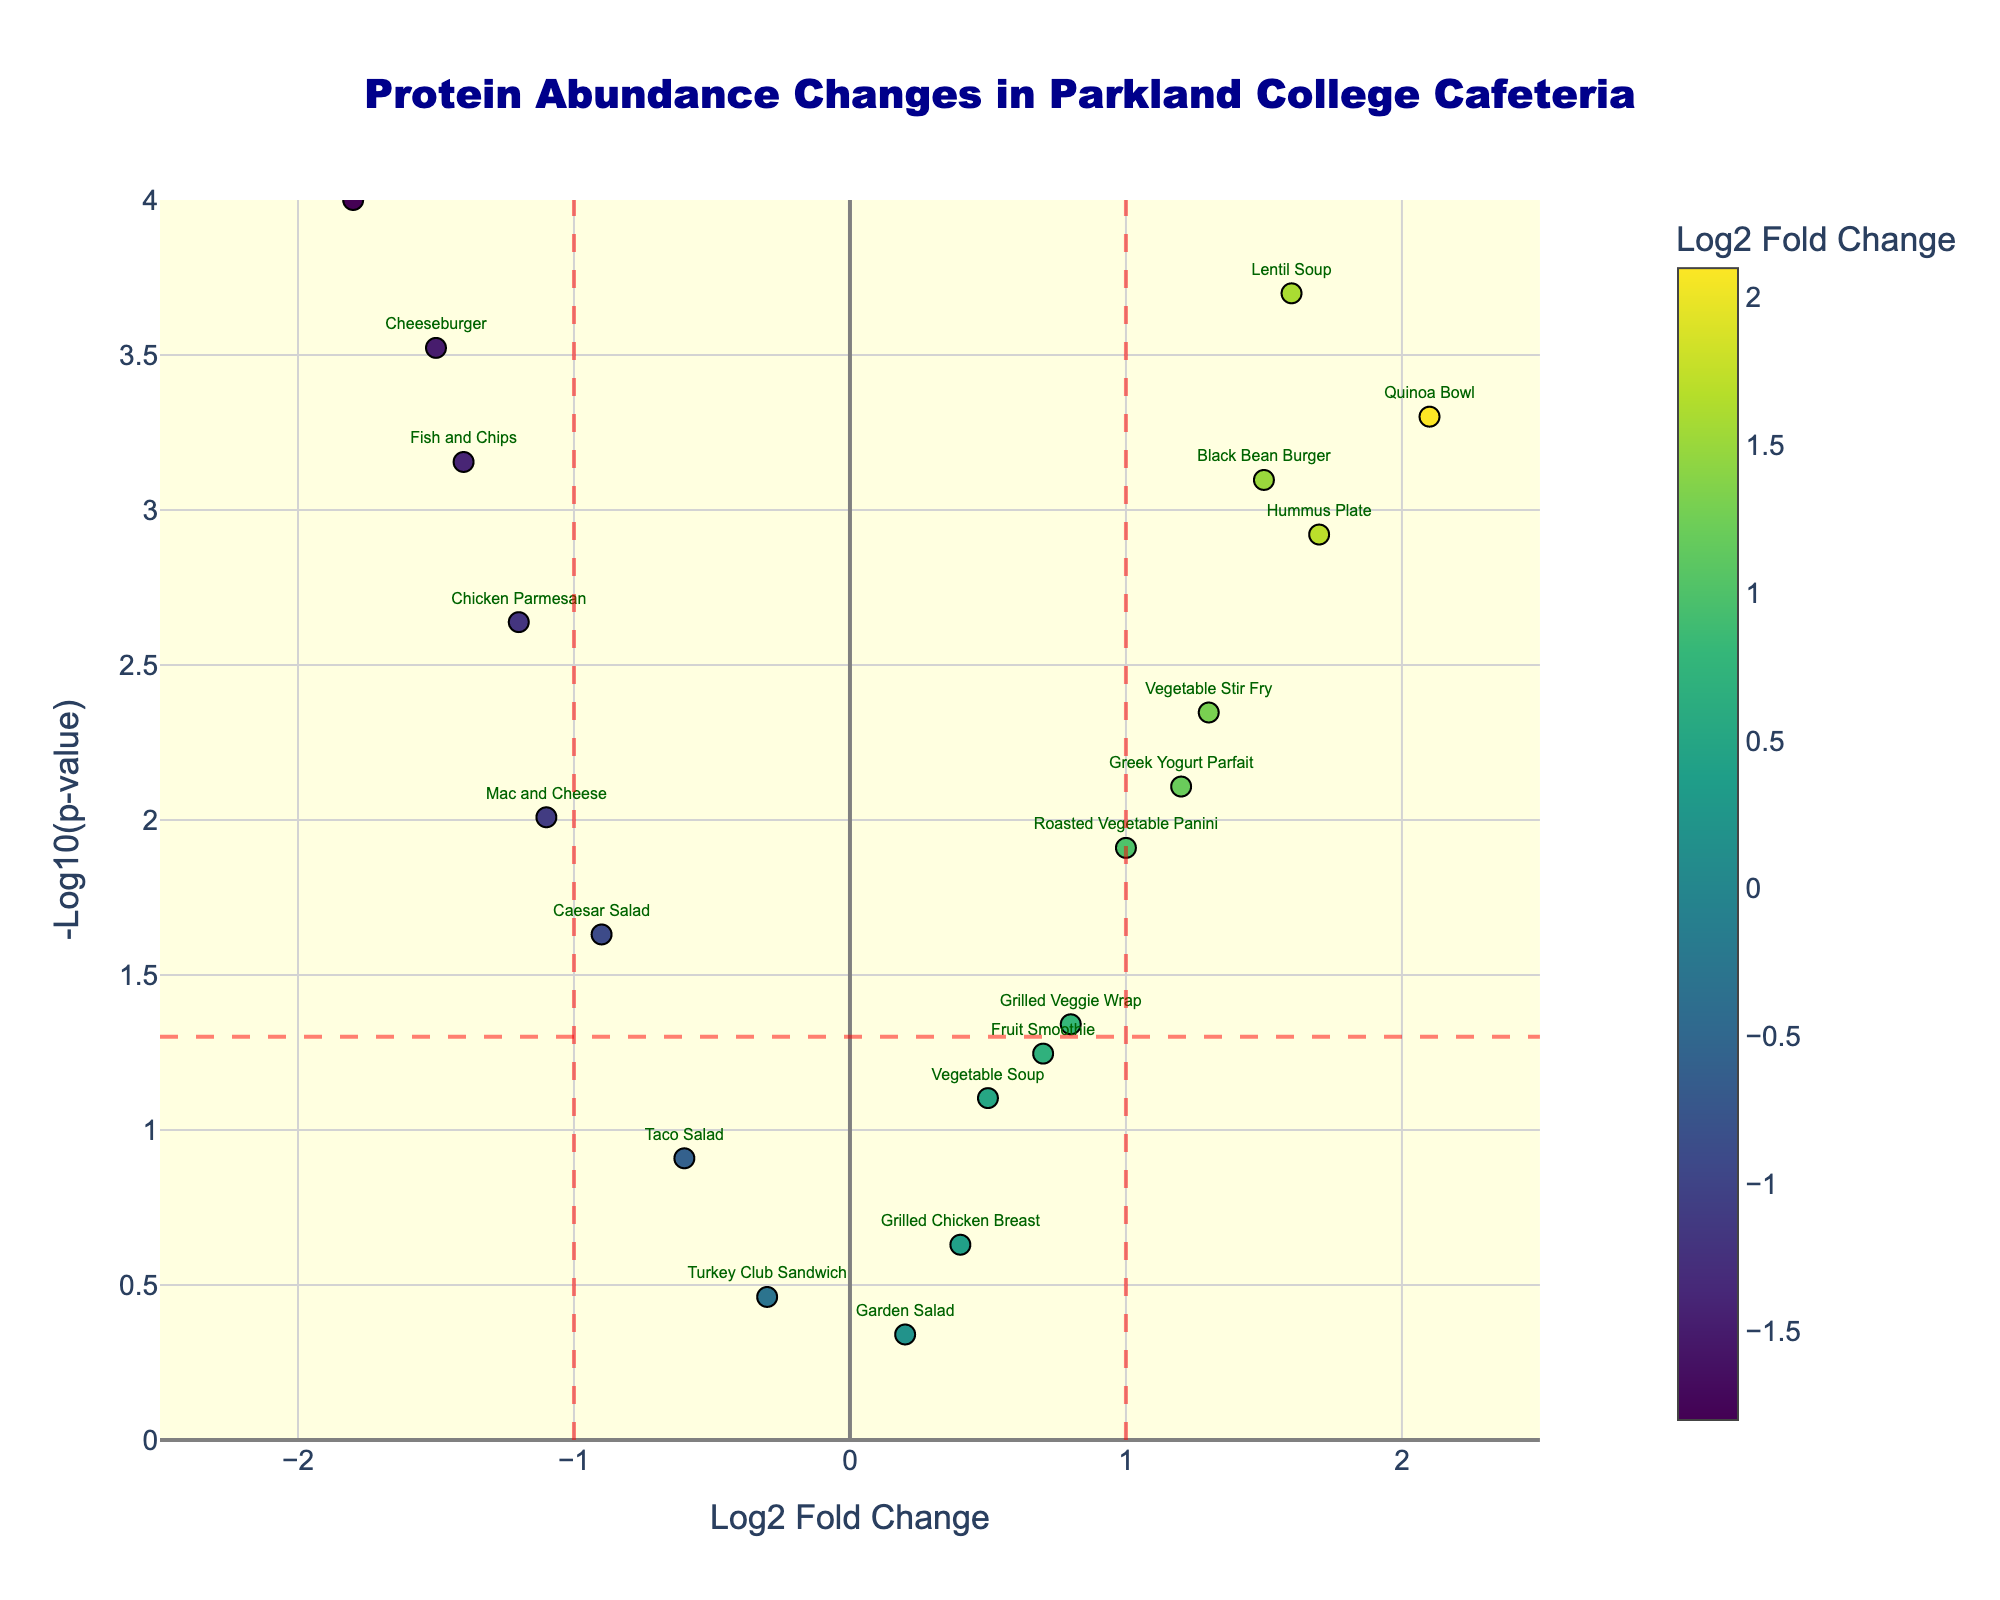What's the title of the plot? The title is usually displayed at the top of the plot and provides an overview of the figure. Here, it reads "Protein Abundance Changes in Parkland College Cafeteria."
Answer: Protein Abundance Changes in Parkland College Cafeteria What are the x-axis and y-axis titles? The x-axis and y-axis titles help understand what measurements are used. In this plot, the x-axis title is "Log2 Fold Change," and the y-axis title is "-Log10(p-value)."
Answer: Log2 Fold Change, -Log10(p-value) Which protein has the highest -log10(p-value)? By observing the y-axis values, the highest -log10(p-value) is 4 (indicating the smallest p-value), and the corresponding protein text label is "Spinach Artichoke Dip."
Answer: Spinach Artichoke Dip Which protein shows the most significant increase in abundance after the menu update? The most significant increase in abundance will have the highest positive log2FoldChange. "Quinoa Bowl" with a log2FoldChange of 2.1 has the highest positive value.
Answer: Quinoa Bowl How many proteins are significantly different before and after the menu update? Significant differences are marked by points outside the vertical lines at x = ±1 and above the horizontal significance threshold at -log10(p-value) of 1.3. By counting, there are 8 such significant points.
Answer: 8 Which protein has the most significant decrease in abundance after the menu update? A significant decrease is represented by a high negative log2FoldChange. "Spinach Artichoke Dip" with a log2FoldChange of -1.8 has the lowest value.
Answer: Spinach Artichoke Dip Is the Cheeseburger more or less abundant after the menu updates? The Cheeseburger's log2FoldChange is negative (-1.5), indicating it is less abundant.
Answer: Less abundant What is the significance threshold for the p-value? The threshold for significance is indicated by the horizontal red dashed line on the y-axis, which is set at -log10(p-value) = 1.3, corresponding to a p-value of 0.05.
Answer: 0.05 Are any proteins close to the significance threshold but not quite significant? If so, which ones? Proteins close to but below the significance threshold line (y = 1.3) include "Taco Salad" and "Vegetable Soup." Their -log10(p-value) values are slightly lower than the threshold.
Answer: Taco Salad, Vegetable Soup Which proteins show a fold change (either positive or negative) below 0.5 and above -0.5? Proteins within the range of -0.5 to +0.5 log2FoldChange include "Garden Salad" (0.2), "Grilled Chicken Breast" (0.4), and "Turkey Club Sandwich" (-0.3).
Answer: Garden Salad, Grilled Chicken Breast, Turkey Club Sandwich 